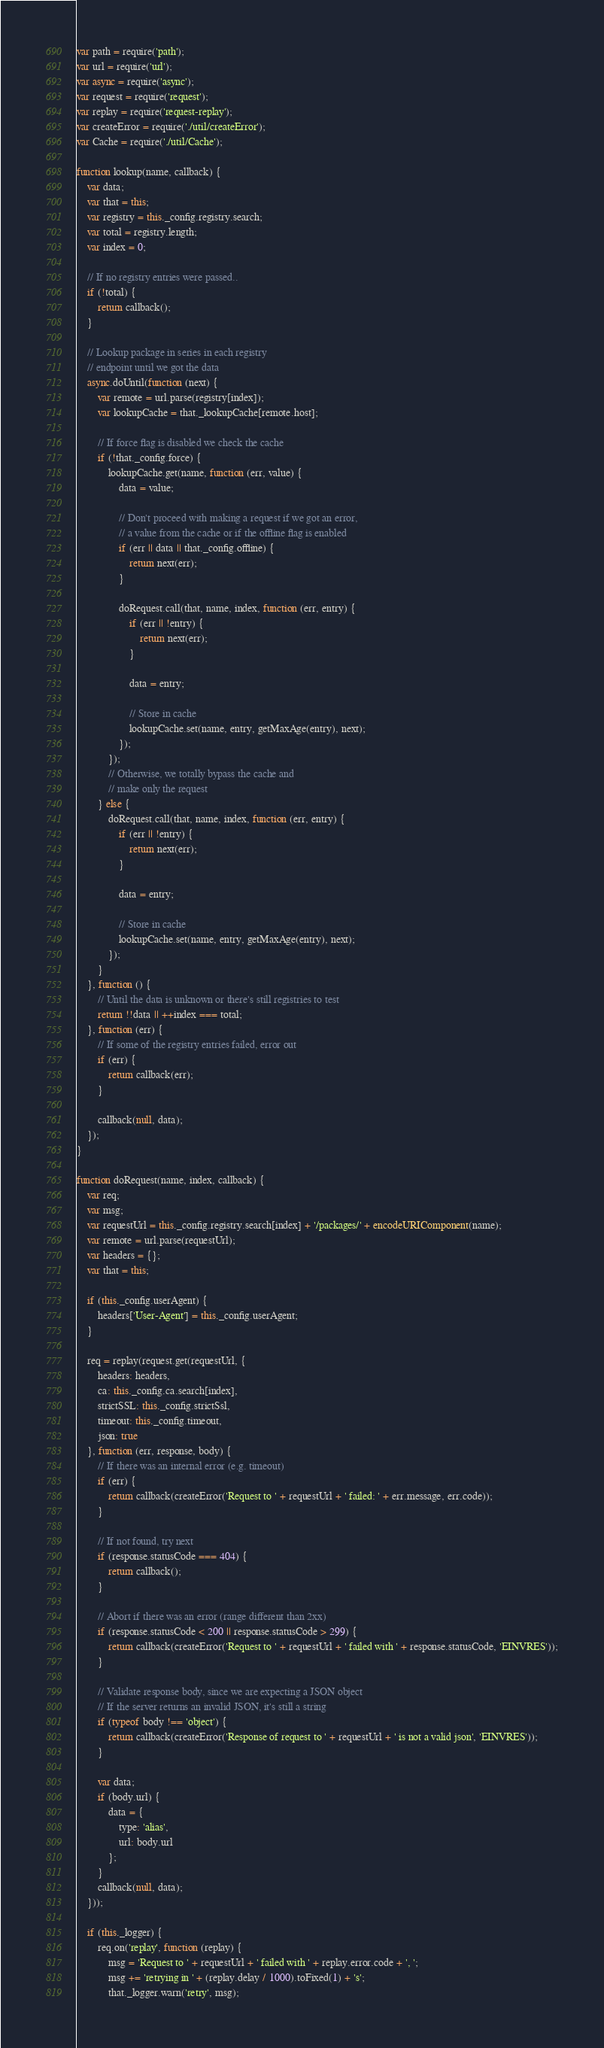Convert code to text. <code><loc_0><loc_0><loc_500><loc_500><_JavaScript_>var path = require('path');
var url = require('url');
var async = require('async');
var request = require('request');
var replay = require('request-replay');
var createError = require('./util/createError');
var Cache = require('./util/Cache');

function lookup(name, callback) {
    var data;
    var that = this;
    var registry = this._config.registry.search;
    var total = registry.length;
    var index = 0;

    // If no registry entries were passed..
    if (!total) {
        return callback();
    }

    // Lookup package in series in each registry
    // endpoint until we got the data
    async.doUntil(function (next) {
        var remote = url.parse(registry[index]);
        var lookupCache = that._lookupCache[remote.host];

        // If force flag is disabled we check the cache
        if (!that._config.force) {
            lookupCache.get(name, function (err, value) {
                data = value;

                // Don't proceed with making a request if we got an error,
                // a value from the cache or if the offline flag is enabled
                if (err || data || that._config.offline) {
                    return next(err);
                }

                doRequest.call(that, name, index, function (err, entry) {
                    if (err || !entry) {
                        return next(err);
                    }

                    data = entry;

                    // Store in cache
                    lookupCache.set(name, entry, getMaxAge(entry), next);
                });
            });
            // Otherwise, we totally bypass the cache and
            // make only the request
        } else {
            doRequest.call(that, name, index, function (err, entry) {
                if (err || !entry) {
                    return next(err);
                }

                data = entry;

                // Store in cache
                lookupCache.set(name, entry, getMaxAge(entry), next);
            });
        }
    }, function () {
        // Until the data is unknown or there's still registries to test
        return !!data || ++index === total;
    }, function (err) {
        // If some of the registry entries failed, error out
        if (err) {
            return callback(err);
        }

        callback(null, data);
    });
}

function doRequest(name, index, callback) {
    var req;
    var msg;
    var requestUrl = this._config.registry.search[index] + '/packages/' + encodeURIComponent(name);
    var remote = url.parse(requestUrl);
    var headers = {};
    var that = this;

    if (this._config.userAgent) {
        headers['User-Agent'] = this._config.userAgent;
    }

    req = replay(request.get(requestUrl, {
        headers: headers,
        ca: this._config.ca.search[index],
        strictSSL: this._config.strictSsl,
        timeout: this._config.timeout,
        json: true
    }, function (err, response, body) {
        // If there was an internal error (e.g. timeout)
        if (err) {
            return callback(createError('Request to ' + requestUrl + ' failed: ' + err.message, err.code));
        }

        // If not found, try next
        if (response.statusCode === 404) {
            return callback();
        }

        // Abort if there was an error (range different than 2xx)
        if (response.statusCode < 200 || response.statusCode > 299) {
            return callback(createError('Request to ' + requestUrl + ' failed with ' + response.statusCode, 'EINVRES'));
        }

        // Validate response body, since we are expecting a JSON object
        // If the server returns an invalid JSON, it's still a string
        if (typeof body !== 'object') {
            return callback(createError('Response of request to ' + requestUrl + ' is not a valid json', 'EINVRES'));
        }

        var data;
        if (body.url) {
            data = {
                type: 'alias',
                url: body.url
            };
        }
        callback(null, data);
    }));

    if (this._logger) {
        req.on('replay', function (replay) {
            msg = 'Request to ' + requestUrl + ' failed with ' + replay.error.code + ', ';
            msg += 'retrying in ' + (replay.delay / 1000).toFixed(1) + 's';
            that._logger.warn('retry', msg);</code> 